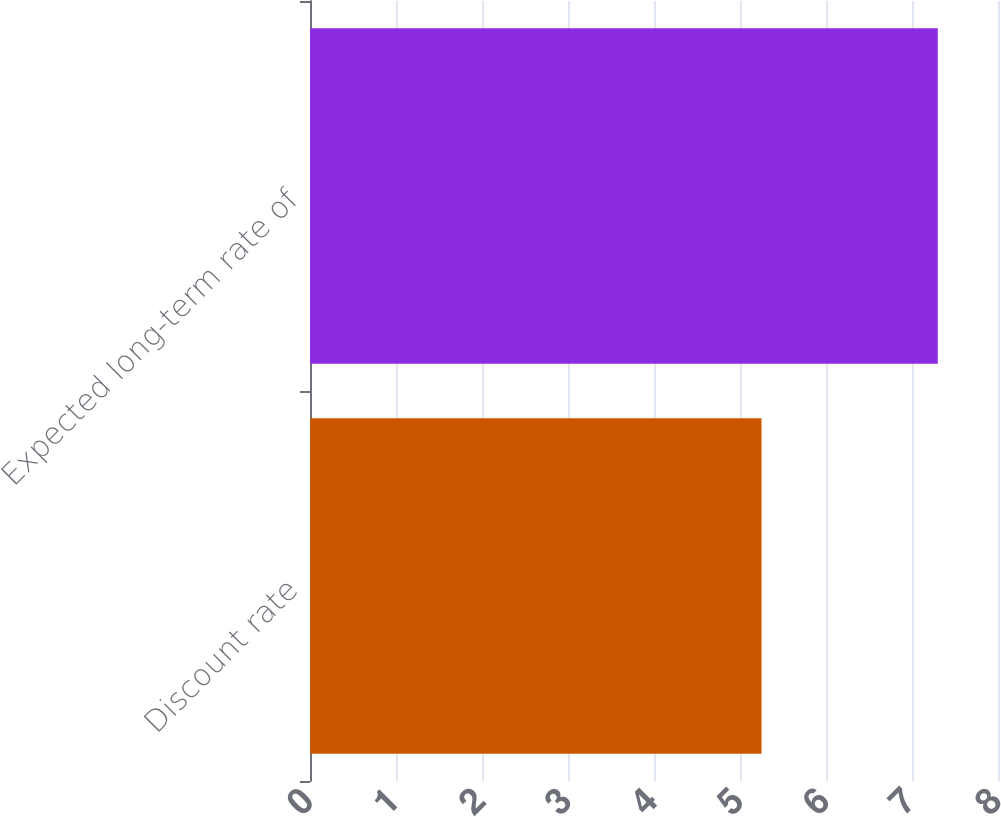<chart> <loc_0><loc_0><loc_500><loc_500><bar_chart><fcel>Discount rate<fcel>Expected long-term rate of<nl><fcel>5.25<fcel>7.3<nl></chart> 